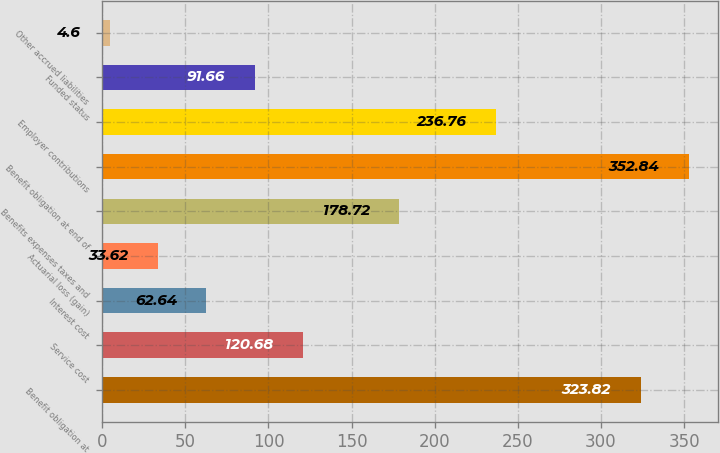Convert chart to OTSL. <chart><loc_0><loc_0><loc_500><loc_500><bar_chart><fcel>Benefit obligation at<fcel>Service cost<fcel>Interest cost<fcel>Actuarial loss (gain)<fcel>Benefits expenses taxes and<fcel>Benefit obligation at end of<fcel>Employer contributions<fcel>Funded status<fcel>Other accrued liabilities<nl><fcel>323.82<fcel>120.68<fcel>62.64<fcel>33.62<fcel>178.72<fcel>352.84<fcel>236.76<fcel>91.66<fcel>4.6<nl></chart> 